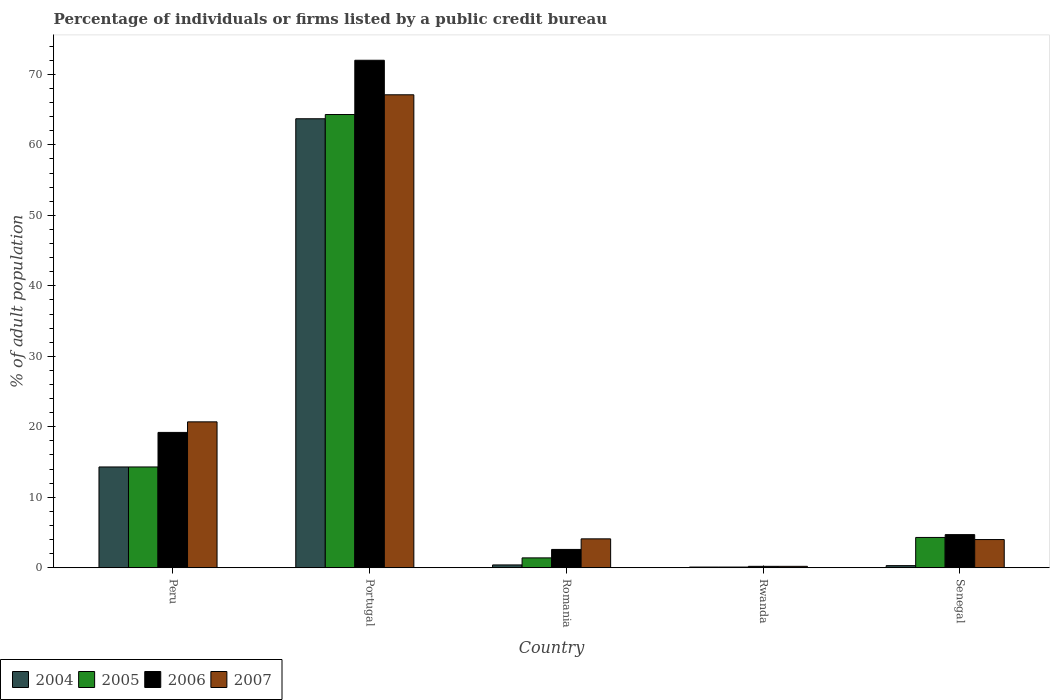How many different coloured bars are there?
Keep it short and to the point. 4. How many groups of bars are there?
Your answer should be compact. 5. Are the number of bars per tick equal to the number of legend labels?
Your answer should be compact. Yes. What is the label of the 5th group of bars from the left?
Keep it short and to the point. Senegal. In how many cases, is the number of bars for a given country not equal to the number of legend labels?
Provide a short and direct response. 0. What is the percentage of population listed by a public credit bureau in 2007 in Romania?
Your response must be concise. 4.1. Across all countries, what is the maximum percentage of population listed by a public credit bureau in 2007?
Make the answer very short. 67.1. In which country was the percentage of population listed by a public credit bureau in 2006 minimum?
Make the answer very short. Rwanda. What is the total percentage of population listed by a public credit bureau in 2007 in the graph?
Your response must be concise. 96.1. What is the difference between the percentage of population listed by a public credit bureau in 2006 in Portugal and that in Rwanda?
Provide a short and direct response. 71.8. What is the difference between the percentage of population listed by a public credit bureau in 2006 in Romania and the percentage of population listed by a public credit bureau in 2007 in Peru?
Give a very brief answer. -18.1. What is the average percentage of population listed by a public credit bureau in 2007 per country?
Provide a succinct answer. 19.22. What is the difference between the percentage of population listed by a public credit bureau of/in 2006 and percentage of population listed by a public credit bureau of/in 2004 in Peru?
Your answer should be very brief. 4.9. What is the ratio of the percentage of population listed by a public credit bureau in 2004 in Peru to that in Rwanda?
Your response must be concise. 143. Is the percentage of population listed by a public credit bureau in 2007 in Peru less than that in Senegal?
Make the answer very short. No. Is the difference between the percentage of population listed by a public credit bureau in 2006 in Peru and Portugal greater than the difference between the percentage of population listed by a public credit bureau in 2004 in Peru and Portugal?
Offer a terse response. No. What is the difference between the highest and the second highest percentage of population listed by a public credit bureau in 2005?
Give a very brief answer. 60. What is the difference between the highest and the lowest percentage of population listed by a public credit bureau in 2005?
Make the answer very short. 64.2. In how many countries, is the percentage of population listed by a public credit bureau in 2006 greater than the average percentage of population listed by a public credit bureau in 2006 taken over all countries?
Your response must be concise. 1. What does the 3rd bar from the left in Peru represents?
Your response must be concise. 2006. Is it the case that in every country, the sum of the percentage of population listed by a public credit bureau in 2007 and percentage of population listed by a public credit bureau in 2004 is greater than the percentage of population listed by a public credit bureau in 2006?
Your answer should be very brief. No. Are the values on the major ticks of Y-axis written in scientific E-notation?
Keep it short and to the point. No. Where does the legend appear in the graph?
Provide a succinct answer. Bottom left. How many legend labels are there?
Offer a terse response. 4. What is the title of the graph?
Keep it short and to the point. Percentage of individuals or firms listed by a public credit bureau. Does "1967" appear as one of the legend labels in the graph?
Ensure brevity in your answer.  No. What is the label or title of the Y-axis?
Your answer should be very brief. % of adult population. What is the % of adult population of 2006 in Peru?
Your answer should be very brief. 19.2. What is the % of adult population of 2007 in Peru?
Give a very brief answer. 20.7. What is the % of adult population in 2004 in Portugal?
Ensure brevity in your answer.  63.7. What is the % of adult population of 2005 in Portugal?
Your response must be concise. 64.3. What is the % of adult population of 2006 in Portugal?
Offer a very short reply. 72. What is the % of adult population of 2007 in Portugal?
Offer a terse response. 67.1. What is the % of adult population in 2006 in Romania?
Your response must be concise. 2.6. What is the % of adult population of 2004 in Rwanda?
Your answer should be very brief. 0.1. What is the % of adult population of 2005 in Rwanda?
Offer a terse response. 0.1. What is the % of adult population of 2007 in Rwanda?
Offer a very short reply. 0.2. What is the % of adult population in 2004 in Senegal?
Your answer should be compact. 0.3. What is the % of adult population of 2005 in Senegal?
Make the answer very short. 4.3. What is the % of adult population of 2006 in Senegal?
Ensure brevity in your answer.  4.7. Across all countries, what is the maximum % of adult population in 2004?
Ensure brevity in your answer.  63.7. Across all countries, what is the maximum % of adult population in 2005?
Give a very brief answer. 64.3. Across all countries, what is the maximum % of adult population in 2007?
Keep it short and to the point. 67.1. Across all countries, what is the minimum % of adult population of 2004?
Your response must be concise. 0.1. Across all countries, what is the minimum % of adult population of 2006?
Your answer should be very brief. 0.2. What is the total % of adult population in 2004 in the graph?
Make the answer very short. 78.8. What is the total % of adult population of 2005 in the graph?
Make the answer very short. 84.4. What is the total % of adult population in 2006 in the graph?
Provide a succinct answer. 98.7. What is the total % of adult population in 2007 in the graph?
Your answer should be compact. 96.1. What is the difference between the % of adult population in 2004 in Peru and that in Portugal?
Make the answer very short. -49.4. What is the difference between the % of adult population of 2005 in Peru and that in Portugal?
Make the answer very short. -50. What is the difference between the % of adult population in 2006 in Peru and that in Portugal?
Give a very brief answer. -52.8. What is the difference between the % of adult population of 2007 in Peru and that in Portugal?
Make the answer very short. -46.4. What is the difference between the % of adult population of 2004 in Peru and that in Romania?
Provide a succinct answer. 13.9. What is the difference between the % of adult population in 2004 in Peru and that in Rwanda?
Ensure brevity in your answer.  14.2. What is the difference between the % of adult population of 2005 in Peru and that in Rwanda?
Your answer should be compact. 14.2. What is the difference between the % of adult population in 2006 in Peru and that in Rwanda?
Ensure brevity in your answer.  19. What is the difference between the % of adult population of 2004 in Peru and that in Senegal?
Make the answer very short. 14. What is the difference between the % of adult population in 2005 in Peru and that in Senegal?
Your answer should be very brief. 10. What is the difference between the % of adult population in 2004 in Portugal and that in Romania?
Give a very brief answer. 63.3. What is the difference between the % of adult population of 2005 in Portugal and that in Romania?
Your answer should be compact. 62.9. What is the difference between the % of adult population of 2006 in Portugal and that in Romania?
Keep it short and to the point. 69.4. What is the difference between the % of adult population in 2007 in Portugal and that in Romania?
Offer a very short reply. 63. What is the difference between the % of adult population in 2004 in Portugal and that in Rwanda?
Make the answer very short. 63.6. What is the difference between the % of adult population of 2005 in Portugal and that in Rwanda?
Make the answer very short. 64.2. What is the difference between the % of adult population of 2006 in Portugal and that in Rwanda?
Make the answer very short. 71.8. What is the difference between the % of adult population in 2007 in Portugal and that in Rwanda?
Keep it short and to the point. 66.9. What is the difference between the % of adult population of 2004 in Portugal and that in Senegal?
Provide a succinct answer. 63.4. What is the difference between the % of adult population of 2005 in Portugal and that in Senegal?
Your answer should be very brief. 60. What is the difference between the % of adult population of 2006 in Portugal and that in Senegal?
Keep it short and to the point. 67.3. What is the difference between the % of adult population in 2007 in Portugal and that in Senegal?
Your answer should be compact. 63.1. What is the difference between the % of adult population of 2005 in Romania and that in Rwanda?
Your answer should be very brief. 1.3. What is the difference between the % of adult population in 2006 in Romania and that in Rwanda?
Give a very brief answer. 2.4. What is the difference between the % of adult population in 2007 in Romania and that in Rwanda?
Provide a succinct answer. 3.9. What is the difference between the % of adult population in 2004 in Romania and that in Senegal?
Your answer should be compact. 0.1. What is the difference between the % of adult population in 2005 in Romania and that in Senegal?
Ensure brevity in your answer.  -2.9. What is the difference between the % of adult population of 2006 in Romania and that in Senegal?
Your answer should be compact. -2.1. What is the difference between the % of adult population in 2007 in Romania and that in Senegal?
Ensure brevity in your answer.  0.1. What is the difference between the % of adult population in 2005 in Rwanda and that in Senegal?
Offer a terse response. -4.2. What is the difference between the % of adult population in 2004 in Peru and the % of adult population in 2006 in Portugal?
Your answer should be compact. -57.7. What is the difference between the % of adult population in 2004 in Peru and the % of adult population in 2007 in Portugal?
Your response must be concise. -52.8. What is the difference between the % of adult population in 2005 in Peru and the % of adult population in 2006 in Portugal?
Keep it short and to the point. -57.7. What is the difference between the % of adult population of 2005 in Peru and the % of adult population of 2007 in Portugal?
Give a very brief answer. -52.8. What is the difference between the % of adult population in 2006 in Peru and the % of adult population in 2007 in Portugal?
Your answer should be very brief. -47.9. What is the difference between the % of adult population in 2004 in Peru and the % of adult population in 2005 in Romania?
Your answer should be very brief. 12.9. What is the difference between the % of adult population of 2004 in Peru and the % of adult population of 2007 in Romania?
Your answer should be very brief. 10.2. What is the difference between the % of adult population of 2005 in Peru and the % of adult population of 2006 in Romania?
Offer a terse response. 11.7. What is the difference between the % of adult population of 2005 in Peru and the % of adult population of 2007 in Romania?
Provide a short and direct response. 10.2. What is the difference between the % of adult population of 2005 in Peru and the % of adult population of 2006 in Rwanda?
Provide a succinct answer. 14.1. What is the difference between the % of adult population of 2005 in Peru and the % of adult population of 2007 in Rwanda?
Provide a short and direct response. 14.1. What is the difference between the % of adult population of 2004 in Peru and the % of adult population of 2005 in Senegal?
Your answer should be very brief. 10. What is the difference between the % of adult population of 2004 in Peru and the % of adult population of 2007 in Senegal?
Your answer should be very brief. 10.3. What is the difference between the % of adult population of 2005 in Peru and the % of adult population of 2006 in Senegal?
Your answer should be very brief. 9.6. What is the difference between the % of adult population of 2005 in Peru and the % of adult population of 2007 in Senegal?
Provide a short and direct response. 10.3. What is the difference between the % of adult population in 2006 in Peru and the % of adult population in 2007 in Senegal?
Provide a succinct answer. 15.2. What is the difference between the % of adult population in 2004 in Portugal and the % of adult population in 2005 in Romania?
Offer a terse response. 62.3. What is the difference between the % of adult population in 2004 in Portugal and the % of adult population in 2006 in Romania?
Offer a terse response. 61.1. What is the difference between the % of adult population in 2004 in Portugal and the % of adult population in 2007 in Romania?
Offer a very short reply. 59.6. What is the difference between the % of adult population of 2005 in Portugal and the % of adult population of 2006 in Romania?
Provide a short and direct response. 61.7. What is the difference between the % of adult population of 2005 in Portugal and the % of adult population of 2007 in Romania?
Offer a terse response. 60.2. What is the difference between the % of adult population of 2006 in Portugal and the % of adult population of 2007 in Romania?
Provide a succinct answer. 67.9. What is the difference between the % of adult population of 2004 in Portugal and the % of adult population of 2005 in Rwanda?
Keep it short and to the point. 63.6. What is the difference between the % of adult population in 2004 in Portugal and the % of adult population in 2006 in Rwanda?
Make the answer very short. 63.5. What is the difference between the % of adult population of 2004 in Portugal and the % of adult population of 2007 in Rwanda?
Offer a very short reply. 63.5. What is the difference between the % of adult population of 2005 in Portugal and the % of adult population of 2006 in Rwanda?
Your answer should be very brief. 64.1. What is the difference between the % of adult population in 2005 in Portugal and the % of adult population in 2007 in Rwanda?
Provide a short and direct response. 64.1. What is the difference between the % of adult population of 2006 in Portugal and the % of adult population of 2007 in Rwanda?
Your answer should be compact. 71.8. What is the difference between the % of adult population of 2004 in Portugal and the % of adult population of 2005 in Senegal?
Ensure brevity in your answer.  59.4. What is the difference between the % of adult population in 2004 in Portugal and the % of adult population in 2006 in Senegal?
Your answer should be compact. 59. What is the difference between the % of adult population of 2004 in Portugal and the % of adult population of 2007 in Senegal?
Your answer should be very brief. 59.7. What is the difference between the % of adult population of 2005 in Portugal and the % of adult population of 2006 in Senegal?
Ensure brevity in your answer.  59.6. What is the difference between the % of adult population in 2005 in Portugal and the % of adult population in 2007 in Senegal?
Provide a short and direct response. 60.3. What is the difference between the % of adult population in 2004 in Romania and the % of adult population in 2006 in Rwanda?
Provide a succinct answer. 0.2. What is the difference between the % of adult population of 2004 in Romania and the % of adult population of 2007 in Rwanda?
Your answer should be compact. 0.2. What is the difference between the % of adult population of 2005 in Romania and the % of adult population of 2006 in Rwanda?
Make the answer very short. 1.2. What is the difference between the % of adult population in 2005 in Romania and the % of adult population in 2007 in Rwanda?
Give a very brief answer. 1.2. What is the difference between the % of adult population of 2006 in Romania and the % of adult population of 2007 in Rwanda?
Keep it short and to the point. 2.4. What is the difference between the % of adult population in 2004 in Romania and the % of adult population in 2005 in Senegal?
Offer a very short reply. -3.9. What is the difference between the % of adult population of 2005 in Romania and the % of adult population of 2007 in Senegal?
Your response must be concise. -2.6. What is the difference between the % of adult population of 2006 in Romania and the % of adult population of 2007 in Senegal?
Your answer should be very brief. -1.4. What is the difference between the % of adult population of 2004 in Rwanda and the % of adult population of 2005 in Senegal?
Ensure brevity in your answer.  -4.2. What is the difference between the % of adult population of 2005 in Rwanda and the % of adult population of 2006 in Senegal?
Your answer should be compact. -4.6. What is the difference between the % of adult population of 2006 in Rwanda and the % of adult population of 2007 in Senegal?
Offer a terse response. -3.8. What is the average % of adult population in 2004 per country?
Offer a terse response. 15.76. What is the average % of adult population of 2005 per country?
Keep it short and to the point. 16.88. What is the average % of adult population in 2006 per country?
Provide a short and direct response. 19.74. What is the average % of adult population of 2007 per country?
Make the answer very short. 19.22. What is the difference between the % of adult population in 2004 and % of adult population in 2006 in Peru?
Give a very brief answer. -4.9. What is the difference between the % of adult population of 2006 and % of adult population of 2007 in Portugal?
Your response must be concise. 4.9. What is the difference between the % of adult population in 2004 and % of adult population in 2005 in Romania?
Make the answer very short. -1. What is the difference between the % of adult population of 2004 and % of adult population of 2006 in Romania?
Provide a succinct answer. -2.2. What is the difference between the % of adult population of 2004 and % of adult population of 2007 in Romania?
Your response must be concise. -3.7. What is the difference between the % of adult population in 2005 and % of adult population in 2007 in Romania?
Keep it short and to the point. -2.7. What is the difference between the % of adult population in 2004 and % of adult population in 2005 in Rwanda?
Your response must be concise. 0. What is the difference between the % of adult population in 2004 and % of adult population in 2006 in Rwanda?
Your answer should be compact. -0.1. What is the difference between the % of adult population of 2004 and % of adult population of 2007 in Rwanda?
Give a very brief answer. -0.1. What is the difference between the % of adult population in 2005 and % of adult population in 2006 in Rwanda?
Give a very brief answer. -0.1. What is the difference between the % of adult population of 2006 and % of adult population of 2007 in Rwanda?
Give a very brief answer. 0. What is the difference between the % of adult population of 2004 and % of adult population of 2005 in Senegal?
Offer a terse response. -4. What is the difference between the % of adult population in 2004 and % of adult population in 2006 in Senegal?
Provide a short and direct response. -4.4. What is the difference between the % of adult population of 2005 and % of adult population of 2006 in Senegal?
Your answer should be very brief. -0.4. What is the difference between the % of adult population of 2005 and % of adult population of 2007 in Senegal?
Your response must be concise. 0.3. What is the ratio of the % of adult population of 2004 in Peru to that in Portugal?
Make the answer very short. 0.22. What is the ratio of the % of adult population in 2005 in Peru to that in Portugal?
Give a very brief answer. 0.22. What is the ratio of the % of adult population in 2006 in Peru to that in Portugal?
Offer a very short reply. 0.27. What is the ratio of the % of adult population of 2007 in Peru to that in Portugal?
Your answer should be very brief. 0.31. What is the ratio of the % of adult population of 2004 in Peru to that in Romania?
Your response must be concise. 35.75. What is the ratio of the % of adult population in 2005 in Peru to that in Romania?
Offer a terse response. 10.21. What is the ratio of the % of adult population in 2006 in Peru to that in Romania?
Offer a very short reply. 7.38. What is the ratio of the % of adult population in 2007 in Peru to that in Romania?
Make the answer very short. 5.05. What is the ratio of the % of adult population of 2004 in Peru to that in Rwanda?
Provide a succinct answer. 143. What is the ratio of the % of adult population in 2005 in Peru to that in Rwanda?
Provide a short and direct response. 143. What is the ratio of the % of adult population of 2006 in Peru to that in Rwanda?
Provide a succinct answer. 96. What is the ratio of the % of adult population in 2007 in Peru to that in Rwanda?
Provide a short and direct response. 103.5. What is the ratio of the % of adult population in 2004 in Peru to that in Senegal?
Your answer should be very brief. 47.67. What is the ratio of the % of adult population in 2005 in Peru to that in Senegal?
Keep it short and to the point. 3.33. What is the ratio of the % of adult population of 2006 in Peru to that in Senegal?
Your answer should be very brief. 4.09. What is the ratio of the % of adult population of 2007 in Peru to that in Senegal?
Offer a very short reply. 5.17. What is the ratio of the % of adult population of 2004 in Portugal to that in Romania?
Offer a very short reply. 159.25. What is the ratio of the % of adult population of 2005 in Portugal to that in Romania?
Your answer should be compact. 45.93. What is the ratio of the % of adult population of 2006 in Portugal to that in Romania?
Provide a short and direct response. 27.69. What is the ratio of the % of adult population in 2007 in Portugal to that in Romania?
Give a very brief answer. 16.37. What is the ratio of the % of adult population in 2004 in Portugal to that in Rwanda?
Ensure brevity in your answer.  637. What is the ratio of the % of adult population in 2005 in Portugal to that in Rwanda?
Provide a succinct answer. 643. What is the ratio of the % of adult population of 2006 in Portugal to that in Rwanda?
Provide a succinct answer. 360. What is the ratio of the % of adult population in 2007 in Portugal to that in Rwanda?
Your answer should be very brief. 335.5. What is the ratio of the % of adult population of 2004 in Portugal to that in Senegal?
Offer a very short reply. 212.33. What is the ratio of the % of adult population in 2005 in Portugal to that in Senegal?
Provide a short and direct response. 14.95. What is the ratio of the % of adult population in 2006 in Portugal to that in Senegal?
Keep it short and to the point. 15.32. What is the ratio of the % of adult population of 2007 in Portugal to that in Senegal?
Offer a terse response. 16.77. What is the ratio of the % of adult population in 2005 in Romania to that in Rwanda?
Make the answer very short. 14. What is the ratio of the % of adult population of 2006 in Romania to that in Rwanda?
Offer a very short reply. 13. What is the ratio of the % of adult population in 2004 in Romania to that in Senegal?
Your answer should be very brief. 1.33. What is the ratio of the % of adult population in 2005 in Romania to that in Senegal?
Ensure brevity in your answer.  0.33. What is the ratio of the % of adult population of 2006 in Romania to that in Senegal?
Ensure brevity in your answer.  0.55. What is the ratio of the % of adult population of 2005 in Rwanda to that in Senegal?
Your answer should be very brief. 0.02. What is the ratio of the % of adult population of 2006 in Rwanda to that in Senegal?
Your response must be concise. 0.04. What is the ratio of the % of adult population of 2007 in Rwanda to that in Senegal?
Your answer should be very brief. 0.05. What is the difference between the highest and the second highest % of adult population of 2004?
Your answer should be very brief. 49.4. What is the difference between the highest and the second highest % of adult population in 2005?
Give a very brief answer. 50. What is the difference between the highest and the second highest % of adult population in 2006?
Make the answer very short. 52.8. What is the difference between the highest and the second highest % of adult population of 2007?
Give a very brief answer. 46.4. What is the difference between the highest and the lowest % of adult population in 2004?
Your answer should be compact. 63.6. What is the difference between the highest and the lowest % of adult population in 2005?
Your answer should be very brief. 64.2. What is the difference between the highest and the lowest % of adult population in 2006?
Your answer should be compact. 71.8. What is the difference between the highest and the lowest % of adult population of 2007?
Provide a succinct answer. 66.9. 